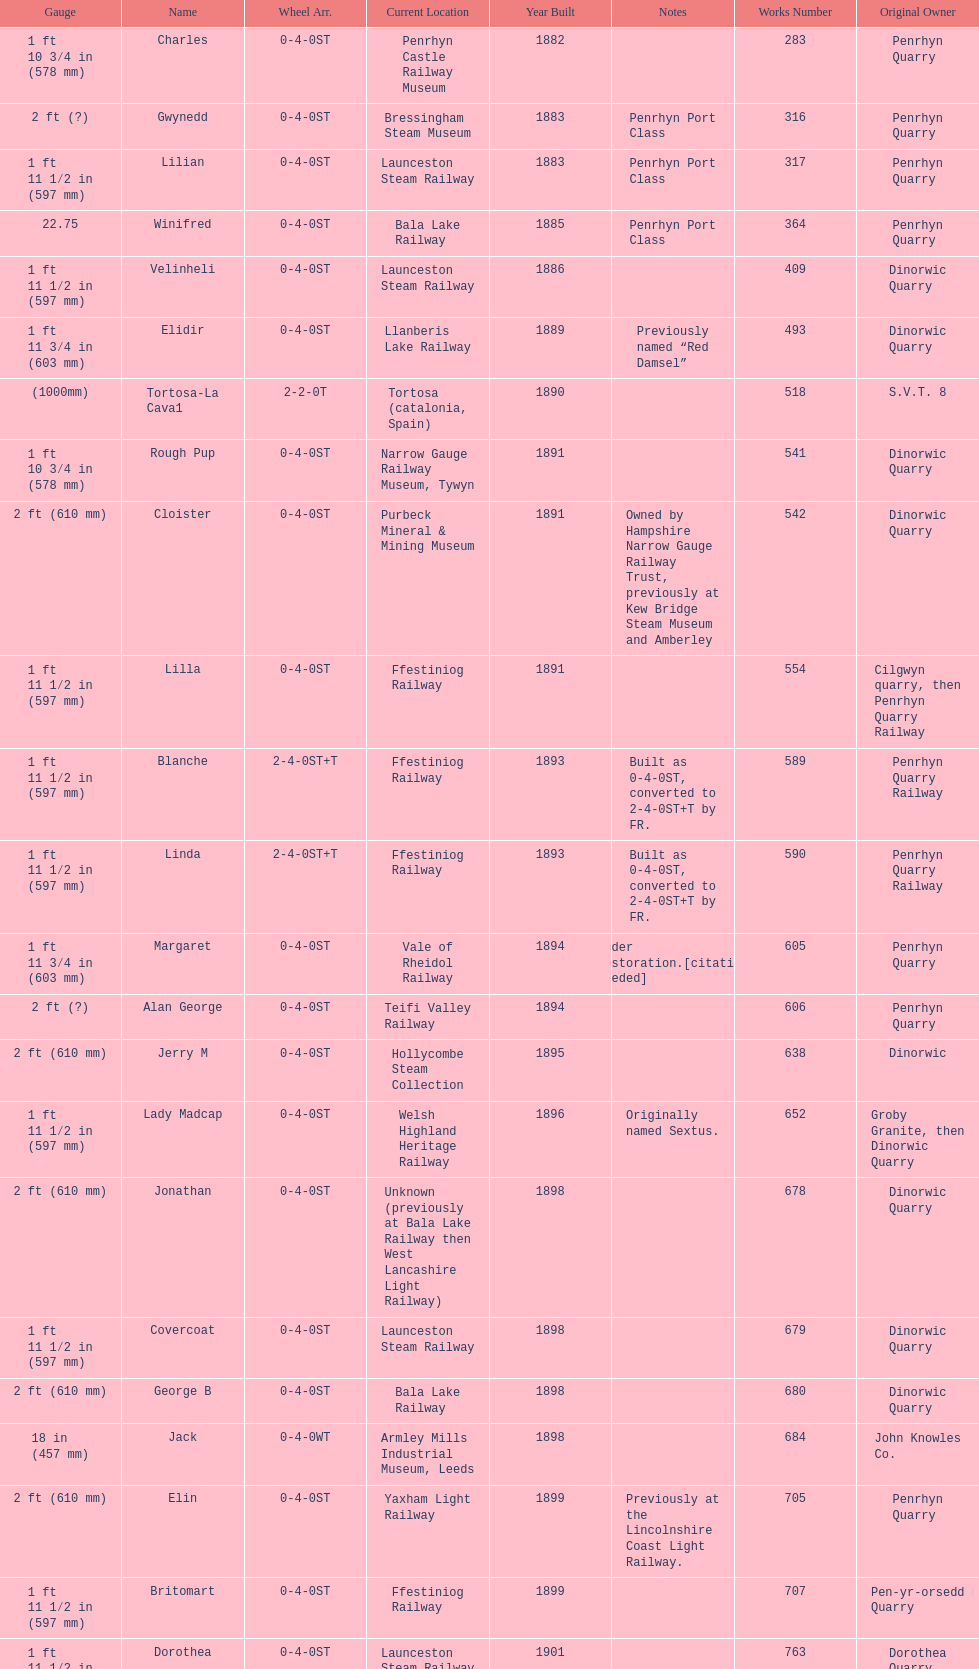Which works number had a larger gauge, 283 or 317? 317. 